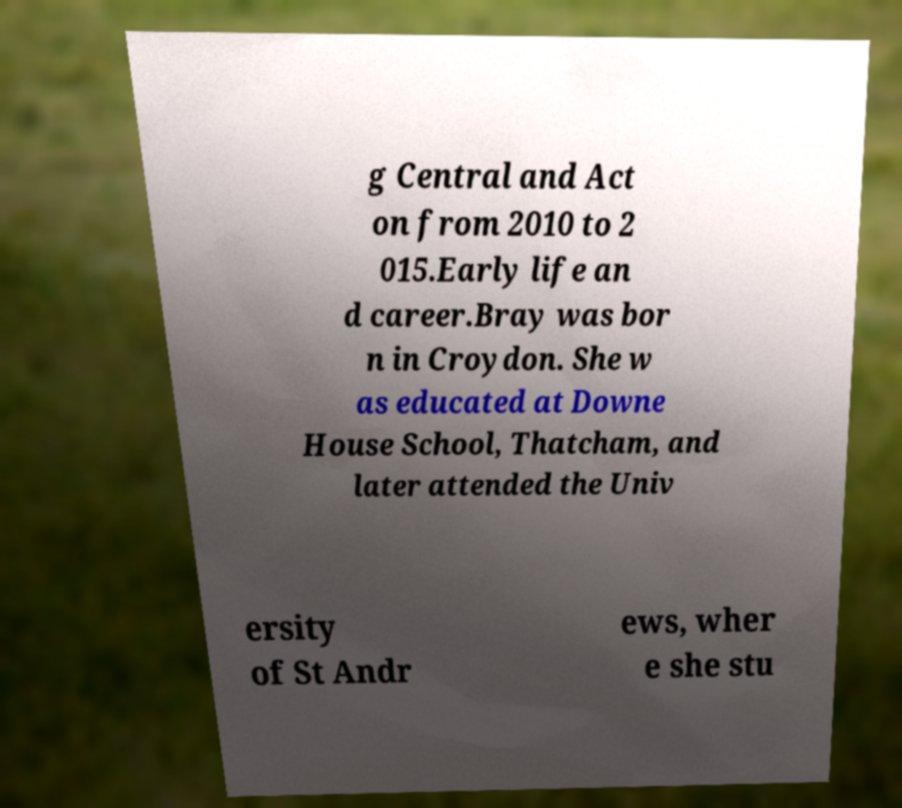For documentation purposes, I need the text within this image transcribed. Could you provide that? g Central and Act on from 2010 to 2 015.Early life an d career.Bray was bor n in Croydon. She w as educated at Downe House School, Thatcham, and later attended the Univ ersity of St Andr ews, wher e she stu 